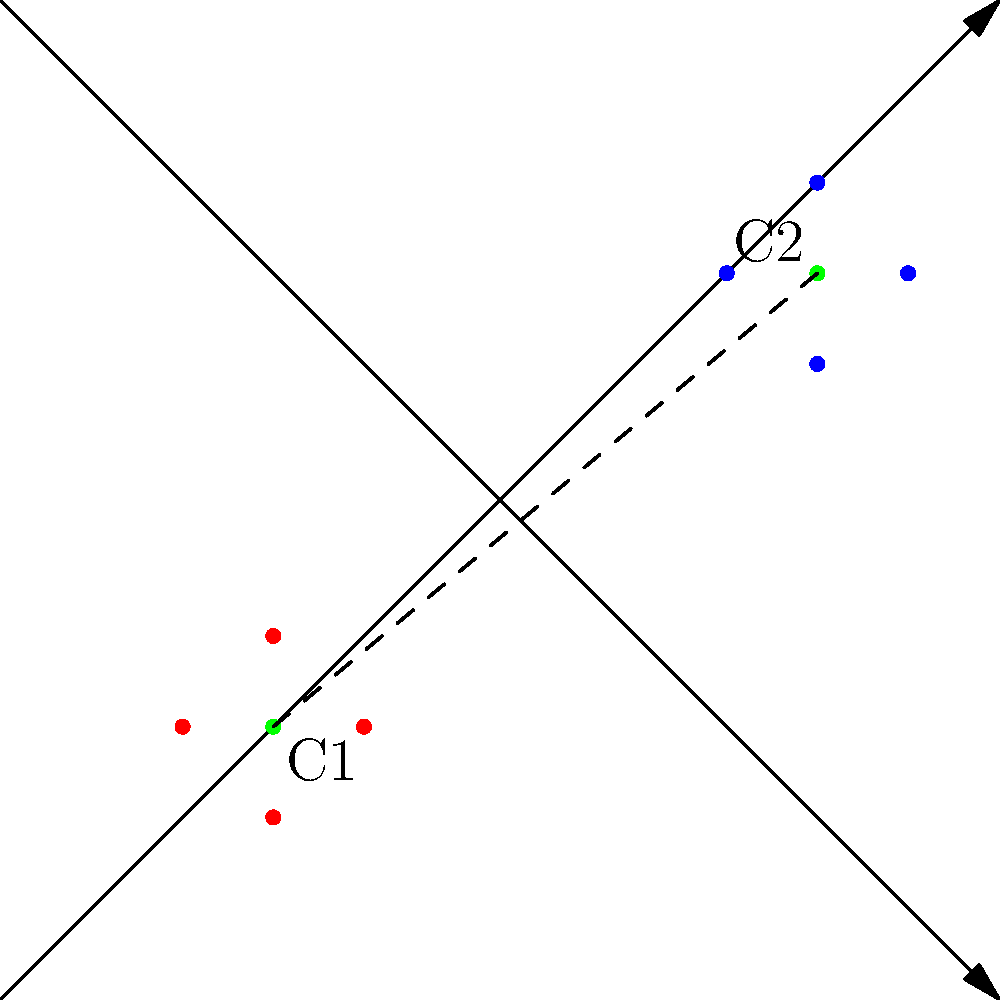As a data analyst working on a research project, you need to calculate the Euclidean distance between two data clusters in a 2D space. Given the centroids of two clusters, C1(2,2) and C2(8,7), calculate the distance between these clusters. To calculate the Euclidean distance between two points in a 2D space, we use the distance formula:

$$ d = \sqrt{(x_2 - x_1)^2 + (y_2 - y_1)^2} $$

Where $(x_1, y_1)$ are the coordinates of the first point and $(x_2, y_2)$ are the coordinates of the second point.

Step 1: Identify the coordinates
C1: $(x_1, y_1) = (2, 2)$
C2: $(x_2, y_2) = (8, 7)$

Step 2: Calculate the differences
$x_2 - x_1 = 8 - 2 = 6$
$y_2 - y_1 = 7 - 2 = 5$

Step 3: Square the differences
$(x_2 - x_1)^2 = 6^2 = 36$
$(y_2 - y_1)^2 = 5^2 = 25$

Step 4: Sum the squared differences
$36 + 25 = 61$

Step 5: Calculate the square root of the sum
$d = \sqrt{61}$

The exact distance is $\sqrt{61}$, which is approximately 7.81 units.
Answer: $\sqrt{61}$ units 